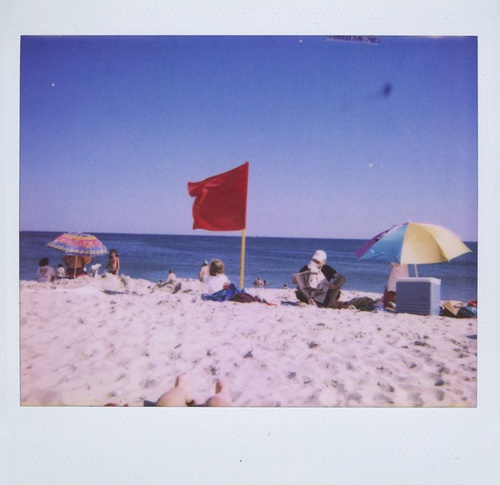Describe the objects in this image and their specific colors. I can see umbrella in lightgray, tan, and gray tones, people in lightgray, gray, black, and pink tones, umbrella in lightgray, violet, darkgray, and purple tones, people in lightgray, blue, lavender, pink, and purple tones, and people in lightgray, maroon, brown, and purple tones in this image. 